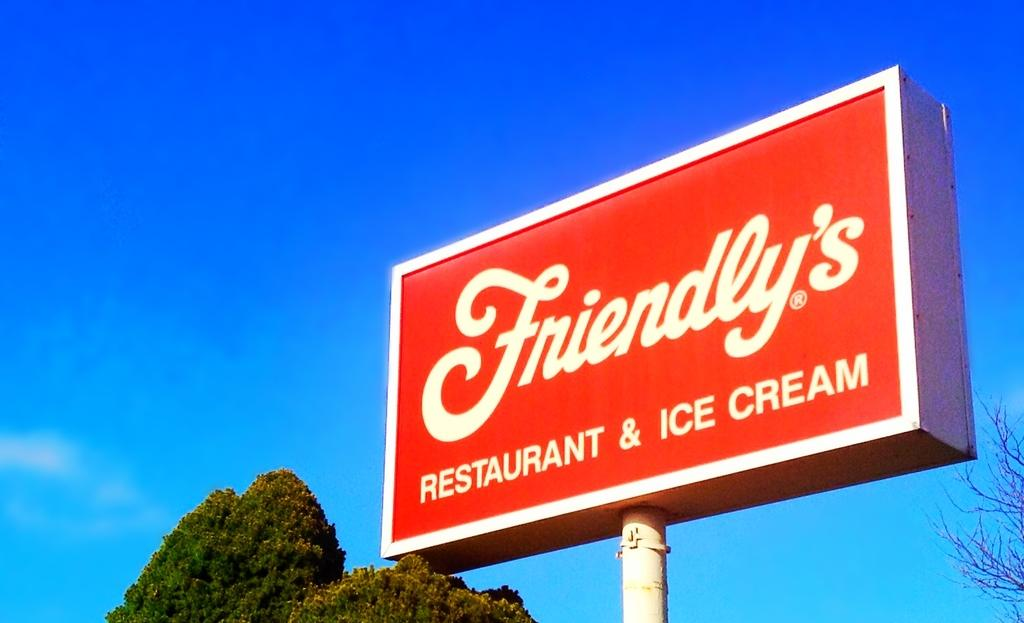<image>
Write a terse but informative summary of the picture. A blue sky is behind a large sign that says Friendly's. 